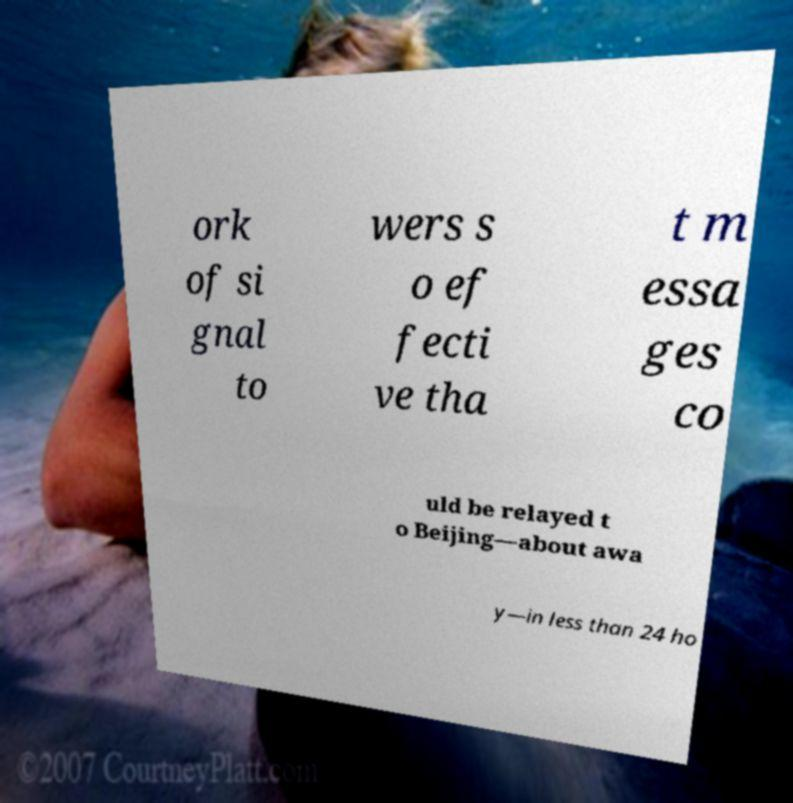Can you accurately transcribe the text from the provided image for me? ork of si gnal to wers s o ef fecti ve tha t m essa ges co uld be relayed t o Beijing—about awa y—in less than 24 ho 